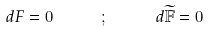Convert formula to latex. <formula><loc_0><loc_0><loc_500><loc_500>d F = 0 \quad \ \ ; \quad \ \ d \widetilde { \mathbb { F } } = 0</formula> 